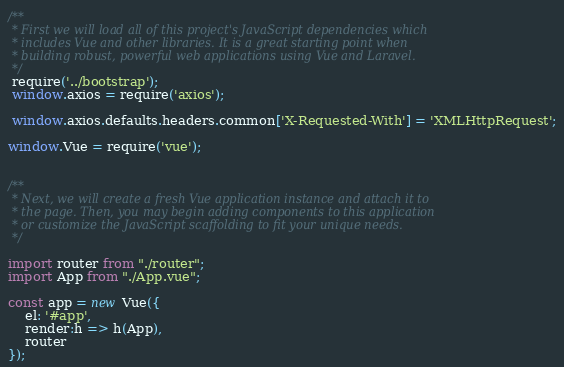Convert code to text. <code><loc_0><loc_0><loc_500><loc_500><_JavaScript_>/**
 * First we will load all of this project's JavaScript dependencies which
 * includes Vue and other libraries. It is a great starting point when
 * building robust, powerful web applications using Vue and Laravel.
 */
 require('../bootstrap');
 window.axios = require('axios');

 window.axios.defaults.headers.common['X-Requested-With'] = 'XMLHttpRequest';

window.Vue = require('vue');


/**
 * Next, we will create a fresh Vue application instance and attach it to
 * the page. Then, you may begin adding components to this application
 * or customize the JavaScript scaffolding to fit your unique needs.
 */

import router from "./router";
import App from "./App.vue";

const app = new Vue({
    el: '#app',
    render:h => h(App),
    router
});
</code> 